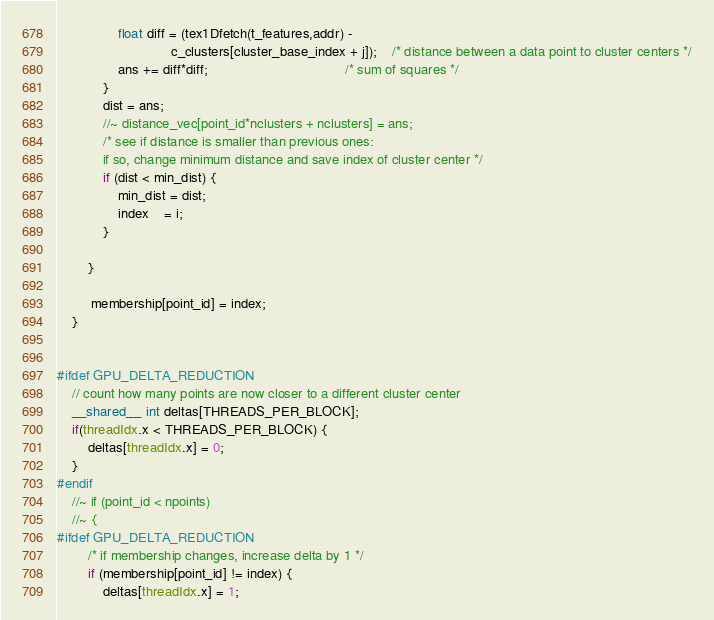Convert code to text. <code><loc_0><loc_0><loc_500><loc_500><_Cuda_>				float diff = (tex1Dfetch(t_features,addr) -
							  c_clusters[cluster_base_index + j]);	/* distance between a data point to cluster centers */
				ans += diff*diff;									/* sum of squares */
			}
			dist = ans;		
			//~ distance_vec[point_id*nclusters + nclusters] = ans;
			/* see if distance is smaller than previous ones:
			if so, change minimum distance and save index of cluster center */
			if (dist < min_dist) {
				min_dist = dist;
				index    = i;
			}
			
		}
		
		 membership[point_id] = index;
	}
	

#ifdef GPU_DELTA_REDUCTION
    // count how many points are now closer to a different cluster center	
	__shared__ int deltas[THREADS_PER_BLOCK];
	if(threadIdx.x < THREADS_PER_BLOCK) {
		deltas[threadIdx.x] = 0;
	}
#endif
	//~ if (point_id < npoints)
	//~ {
#ifdef GPU_DELTA_REDUCTION
		/* if membership changes, increase delta by 1 */
		if (membership[point_id] != index) {
			deltas[threadIdx.x] = 1;</code> 